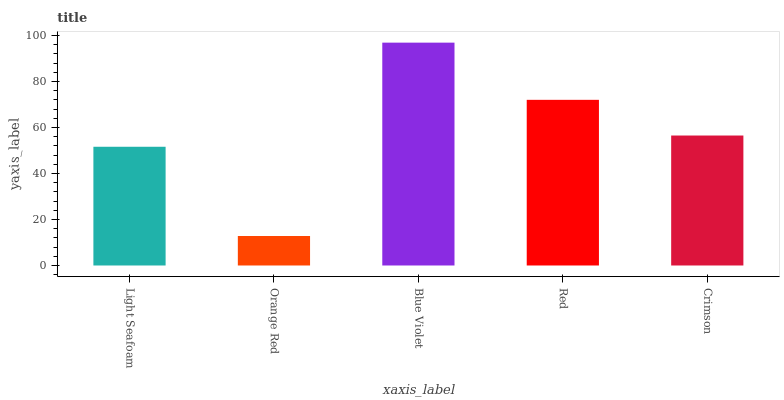Is Orange Red the minimum?
Answer yes or no. Yes. Is Blue Violet the maximum?
Answer yes or no. Yes. Is Blue Violet the minimum?
Answer yes or no. No. Is Orange Red the maximum?
Answer yes or no. No. Is Blue Violet greater than Orange Red?
Answer yes or no. Yes. Is Orange Red less than Blue Violet?
Answer yes or no. Yes. Is Orange Red greater than Blue Violet?
Answer yes or no. No. Is Blue Violet less than Orange Red?
Answer yes or no. No. Is Crimson the high median?
Answer yes or no. Yes. Is Crimson the low median?
Answer yes or no. Yes. Is Light Seafoam the high median?
Answer yes or no. No. Is Orange Red the low median?
Answer yes or no. No. 